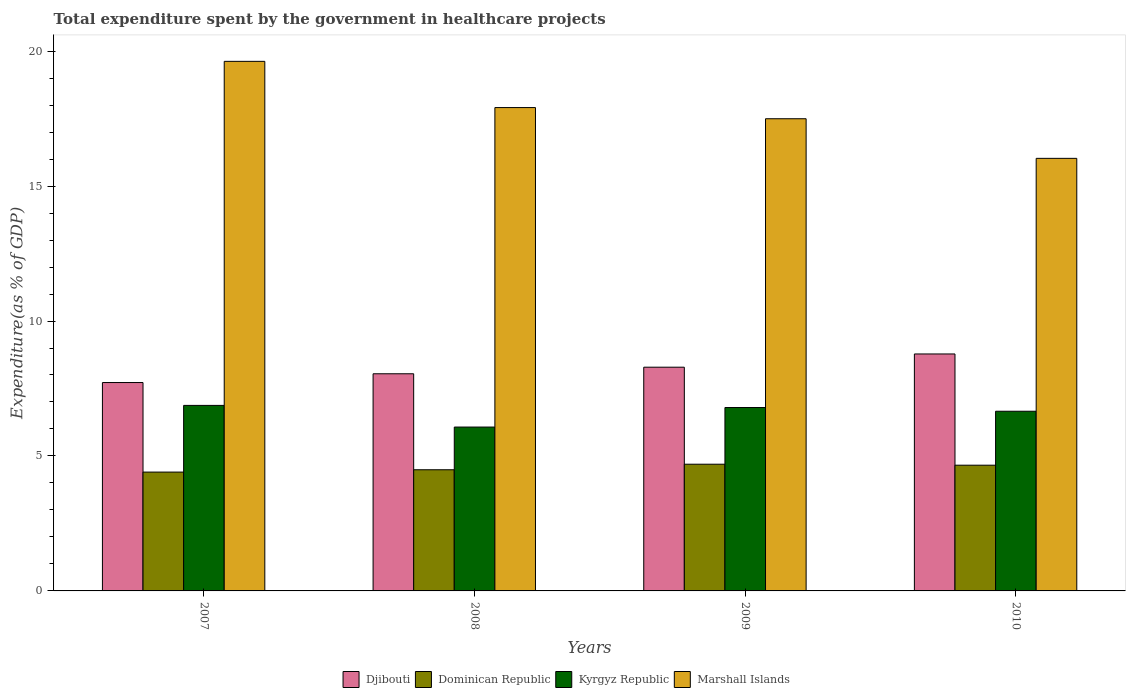Are the number of bars per tick equal to the number of legend labels?
Make the answer very short. Yes. How many bars are there on the 1st tick from the right?
Your answer should be compact. 4. In how many cases, is the number of bars for a given year not equal to the number of legend labels?
Ensure brevity in your answer.  0. What is the total expenditure spent by the government in healthcare projects in Dominican Republic in 2010?
Keep it short and to the point. 4.66. Across all years, what is the maximum total expenditure spent by the government in healthcare projects in Kyrgyz Republic?
Your answer should be compact. 6.87. Across all years, what is the minimum total expenditure spent by the government in healthcare projects in Dominican Republic?
Your answer should be very brief. 4.4. In which year was the total expenditure spent by the government in healthcare projects in Dominican Republic minimum?
Give a very brief answer. 2007. What is the total total expenditure spent by the government in healthcare projects in Djibouti in the graph?
Your answer should be very brief. 32.83. What is the difference between the total expenditure spent by the government in healthcare projects in Dominican Republic in 2009 and that in 2010?
Offer a very short reply. 0.04. What is the difference between the total expenditure spent by the government in healthcare projects in Dominican Republic in 2007 and the total expenditure spent by the government in healthcare projects in Marshall Islands in 2010?
Ensure brevity in your answer.  -11.62. What is the average total expenditure spent by the government in healthcare projects in Kyrgyz Republic per year?
Keep it short and to the point. 6.6. In the year 2008, what is the difference between the total expenditure spent by the government in healthcare projects in Kyrgyz Republic and total expenditure spent by the government in healthcare projects in Dominican Republic?
Your answer should be compact. 1.58. In how many years, is the total expenditure spent by the government in healthcare projects in Dominican Republic greater than 3 %?
Provide a short and direct response. 4. What is the ratio of the total expenditure spent by the government in healthcare projects in Kyrgyz Republic in 2009 to that in 2010?
Give a very brief answer. 1.02. Is the total expenditure spent by the government in healthcare projects in Marshall Islands in 2007 less than that in 2008?
Your response must be concise. No. Is the difference between the total expenditure spent by the government in healthcare projects in Kyrgyz Republic in 2009 and 2010 greater than the difference between the total expenditure spent by the government in healthcare projects in Dominican Republic in 2009 and 2010?
Provide a short and direct response. Yes. What is the difference between the highest and the second highest total expenditure spent by the government in healthcare projects in Kyrgyz Republic?
Your answer should be very brief. 0.08. What is the difference between the highest and the lowest total expenditure spent by the government in healthcare projects in Kyrgyz Republic?
Provide a short and direct response. 0.8. What does the 4th bar from the left in 2009 represents?
Offer a terse response. Marshall Islands. What does the 2nd bar from the right in 2010 represents?
Give a very brief answer. Kyrgyz Republic. How many bars are there?
Ensure brevity in your answer.  16. How many years are there in the graph?
Offer a terse response. 4. Does the graph contain any zero values?
Your answer should be very brief. No. Does the graph contain grids?
Make the answer very short. No. Where does the legend appear in the graph?
Your answer should be compact. Bottom center. How are the legend labels stacked?
Ensure brevity in your answer.  Horizontal. What is the title of the graph?
Make the answer very short. Total expenditure spent by the government in healthcare projects. What is the label or title of the Y-axis?
Ensure brevity in your answer.  Expenditure(as % of GDP). What is the Expenditure(as % of GDP) of Djibouti in 2007?
Your answer should be compact. 7.72. What is the Expenditure(as % of GDP) of Dominican Republic in 2007?
Your answer should be very brief. 4.4. What is the Expenditure(as % of GDP) in Kyrgyz Republic in 2007?
Provide a succinct answer. 6.87. What is the Expenditure(as % of GDP) in Marshall Islands in 2007?
Ensure brevity in your answer.  19.62. What is the Expenditure(as % of GDP) in Djibouti in 2008?
Keep it short and to the point. 8.05. What is the Expenditure(as % of GDP) in Dominican Republic in 2008?
Your response must be concise. 4.49. What is the Expenditure(as % of GDP) of Kyrgyz Republic in 2008?
Give a very brief answer. 6.07. What is the Expenditure(as % of GDP) in Marshall Islands in 2008?
Your answer should be compact. 17.91. What is the Expenditure(as % of GDP) in Djibouti in 2009?
Your answer should be compact. 8.29. What is the Expenditure(as % of GDP) of Dominican Republic in 2009?
Your answer should be very brief. 4.69. What is the Expenditure(as % of GDP) of Kyrgyz Republic in 2009?
Provide a succinct answer. 6.79. What is the Expenditure(as % of GDP) of Marshall Islands in 2009?
Ensure brevity in your answer.  17.49. What is the Expenditure(as % of GDP) in Djibouti in 2010?
Ensure brevity in your answer.  8.78. What is the Expenditure(as % of GDP) in Dominican Republic in 2010?
Offer a very short reply. 4.66. What is the Expenditure(as % of GDP) of Kyrgyz Republic in 2010?
Your answer should be very brief. 6.66. What is the Expenditure(as % of GDP) in Marshall Islands in 2010?
Your response must be concise. 16.03. Across all years, what is the maximum Expenditure(as % of GDP) of Djibouti?
Your answer should be very brief. 8.78. Across all years, what is the maximum Expenditure(as % of GDP) of Dominican Republic?
Your answer should be very brief. 4.69. Across all years, what is the maximum Expenditure(as % of GDP) in Kyrgyz Republic?
Give a very brief answer. 6.87. Across all years, what is the maximum Expenditure(as % of GDP) in Marshall Islands?
Provide a succinct answer. 19.62. Across all years, what is the minimum Expenditure(as % of GDP) in Djibouti?
Ensure brevity in your answer.  7.72. Across all years, what is the minimum Expenditure(as % of GDP) in Dominican Republic?
Offer a terse response. 4.4. Across all years, what is the minimum Expenditure(as % of GDP) of Kyrgyz Republic?
Offer a very short reply. 6.07. Across all years, what is the minimum Expenditure(as % of GDP) of Marshall Islands?
Make the answer very short. 16.03. What is the total Expenditure(as % of GDP) in Djibouti in the graph?
Your answer should be compact. 32.83. What is the total Expenditure(as % of GDP) in Dominican Republic in the graph?
Ensure brevity in your answer.  18.25. What is the total Expenditure(as % of GDP) in Kyrgyz Republic in the graph?
Keep it short and to the point. 26.4. What is the total Expenditure(as % of GDP) in Marshall Islands in the graph?
Your answer should be very brief. 71.05. What is the difference between the Expenditure(as % of GDP) of Djibouti in 2007 and that in 2008?
Offer a very short reply. -0.32. What is the difference between the Expenditure(as % of GDP) of Dominican Republic in 2007 and that in 2008?
Provide a succinct answer. -0.09. What is the difference between the Expenditure(as % of GDP) of Kyrgyz Republic in 2007 and that in 2008?
Keep it short and to the point. 0.8. What is the difference between the Expenditure(as % of GDP) of Marshall Islands in 2007 and that in 2008?
Provide a succinct answer. 1.71. What is the difference between the Expenditure(as % of GDP) in Djibouti in 2007 and that in 2009?
Keep it short and to the point. -0.57. What is the difference between the Expenditure(as % of GDP) of Dominican Republic in 2007 and that in 2009?
Provide a succinct answer. -0.29. What is the difference between the Expenditure(as % of GDP) of Kyrgyz Republic in 2007 and that in 2009?
Provide a succinct answer. 0.08. What is the difference between the Expenditure(as % of GDP) of Marshall Islands in 2007 and that in 2009?
Your answer should be compact. 2.13. What is the difference between the Expenditure(as % of GDP) in Djibouti in 2007 and that in 2010?
Make the answer very short. -1.06. What is the difference between the Expenditure(as % of GDP) of Dominican Republic in 2007 and that in 2010?
Offer a very short reply. -0.26. What is the difference between the Expenditure(as % of GDP) in Kyrgyz Republic in 2007 and that in 2010?
Give a very brief answer. 0.22. What is the difference between the Expenditure(as % of GDP) in Marshall Islands in 2007 and that in 2010?
Provide a succinct answer. 3.59. What is the difference between the Expenditure(as % of GDP) of Djibouti in 2008 and that in 2009?
Provide a short and direct response. -0.24. What is the difference between the Expenditure(as % of GDP) of Dominican Republic in 2008 and that in 2009?
Make the answer very short. -0.21. What is the difference between the Expenditure(as % of GDP) in Kyrgyz Republic in 2008 and that in 2009?
Offer a terse response. -0.72. What is the difference between the Expenditure(as % of GDP) in Marshall Islands in 2008 and that in 2009?
Your answer should be compact. 0.41. What is the difference between the Expenditure(as % of GDP) in Djibouti in 2008 and that in 2010?
Make the answer very short. -0.73. What is the difference between the Expenditure(as % of GDP) of Dominican Republic in 2008 and that in 2010?
Provide a short and direct response. -0.17. What is the difference between the Expenditure(as % of GDP) in Kyrgyz Republic in 2008 and that in 2010?
Provide a succinct answer. -0.59. What is the difference between the Expenditure(as % of GDP) of Marshall Islands in 2008 and that in 2010?
Provide a succinct answer. 1.88. What is the difference between the Expenditure(as % of GDP) in Djibouti in 2009 and that in 2010?
Your answer should be compact. -0.49. What is the difference between the Expenditure(as % of GDP) in Dominican Republic in 2009 and that in 2010?
Provide a short and direct response. 0.04. What is the difference between the Expenditure(as % of GDP) of Kyrgyz Republic in 2009 and that in 2010?
Your answer should be very brief. 0.14. What is the difference between the Expenditure(as % of GDP) of Marshall Islands in 2009 and that in 2010?
Give a very brief answer. 1.47. What is the difference between the Expenditure(as % of GDP) in Djibouti in 2007 and the Expenditure(as % of GDP) in Dominican Republic in 2008?
Provide a succinct answer. 3.23. What is the difference between the Expenditure(as % of GDP) of Djibouti in 2007 and the Expenditure(as % of GDP) of Kyrgyz Republic in 2008?
Provide a succinct answer. 1.65. What is the difference between the Expenditure(as % of GDP) of Djibouti in 2007 and the Expenditure(as % of GDP) of Marshall Islands in 2008?
Ensure brevity in your answer.  -10.19. What is the difference between the Expenditure(as % of GDP) in Dominican Republic in 2007 and the Expenditure(as % of GDP) in Kyrgyz Republic in 2008?
Give a very brief answer. -1.67. What is the difference between the Expenditure(as % of GDP) in Dominican Republic in 2007 and the Expenditure(as % of GDP) in Marshall Islands in 2008?
Offer a very short reply. -13.51. What is the difference between the Expenditure(as % of GDP) of Kyrgyz Republic in 2007 and the Expenditure(as % of GDP) of Marshall Islands in 2008?
Ensure brevity in your answer.  -11.03. What is the difference between the Expenditure(as % of GDP) in Djibouti in 2007 and the Expenditure(as % of GDP) in Dominican Republic in 2009?
Offer a terse response. 3.03. What is the difference between the Expenditure(as % of GDP) in Djibouti in 2007 and the Expenditure(as % of GDP) in Kyrgyz Republic in 2009?
Give a very brief answer. 0.93. What is the difference between the Expenditure(as % of GDP) in Djibouti in 2007 and the Expenditure(as % of GDP) in Marshall Islands in 2009?
Your response must be concise. -9.77. What is the difference between the Expenditure(as % of GDP) of Dominican Republic in 2007 and the Expenditure(as % of GDP) of Kyrgyz Republic in 2009?
Keep it short and to the point. -2.39. What is the difference between the Expenditure(as % of GDP) in Dominican Republic in 2007 and the Expenditure(as % of GDP) in Marshall Islands in 2009?
Your answer should be very brief. -13.09. What is the difference between the Expenditure(as % of GDP) of Kyrgyz Republic in 2007 and the Expenditure(as % of GDP) of Marshall Islands in 2009?
Keep it short and to the point. -10.62. What is the difference between the Expenditure(as % of GDP) in Djibouti in 2007 and the Expenditure(as % of GDP) in Dominican Republic in 2010?
Keep it short and to the point. 3.06. What is the difference between the Expenditure(as % of GDP) in Djibouti in 2007 and the Expenditure(as % of GDP) in Kyrgyz Republic in 2010?
Ensure brevity in your answer.  1.06. What is the difference between the Expenditure(as % of GDP) in Djibouti in 2007 and the Expenditure(as % of GDP) in Marshall Islands in 2010?
Offer a very short reply. -8.31. What is the difference between the Expenditure(as % of GDP) in Dominican Republic in 2007 and the Expenditure(as % of GDP) in Kyrgyz Republic in 2010?
Your answer should be very brief. -2.25. What is the difference between the Expenditure(as % of GDP) in Dominican Republic in 2007 and the Expenditure(as % of GDP) in Marshall Islands in 2010?
Keep it short and to the point. -11.62. What is the difference between the Expenditure(as % of GDP) in Kyrgyz Republic in 2007 and the Expenditure(as % of GDP) in Marshall Islands in 2010?
Keep it short and to the point. -9.15. What is the difference between the Expenditure(as % of GDP) in Djibouti in 2008 and the Expenditure(as % of GDP) in Dominican Republic in 2009?
Offer a terse response. 3.35. What is the difference between the Expenditure(as % of GDP) in Djibouti in 2008 and the Expenditure(as % of GDP) in Kyrgyz Republic in 2009?
Ensure brevity in your answer.  1.25. What is the difference between the Expenditure(as % of GDP) in Djibouti in 2008 and the Expenditure(as % of GDP) in Marshall Islands in 2009?
Give a very brief answer. -9.45. What is the difference between the Expenditure(as % of GDP) in Dominican Republic in 2008 and the Expenditure(as % of GDP) in Kyrgyz Republic in 2009?
Your response must be concise. -2.31. What is the difference between the Expenditure(as % of GDP) in Dominican Republic in 2008 and the Expenditure(as % of GDP) in Marshall Islands in 2009?
Offer a terse response. -13.01. What is the difference between the Expenditure(as % of GDP) in Kyrgyz Republic in 2008 and the Expenditure(as % of GDP) in Marshall Islands in 2009?
Give a very brief answer. -11.42. What is the difference between the Expenditure(as % of GDP) in Djibouti in 2008 and the Expenditure(as % of GDP) in Dominican Republic in 2010?
Provide a short and direct response. 3.39. What is the difference between the Expenditure(as % of GDP) in Djibouti in 2008 and the Expenditure(as % of GDP) in Kyrgyz Republic in 2010?
Offer a terse response. 1.39. What is the difference between the Expenditure(as % of GDP) in Djibouti in 2008 and the Expenditure(as % of GDP) in Marshall Islands in 2010?
Give a very brief answer. -7.98. What is the difference between the Expenditure(as % of GDP) in Dominican Republic in 2008 and the Expenditure(as % of GDP) in Kyrgyz Republic in 2010?
Your answer should be very brief. -2.17. What is the difference between the Expenditure(as % of GDP) in Dominican Republic in 2008 and the Expenditure(as % of GDP) in Marshall Islands in 2010?
Give a very brief answer. -11.54. What is the difference between the Expenditure(as % of GDP) of Kyrgyz Republic in 2008 and the Expenditure(as % of GDP) of Marshall Islands in 2010?
Your response must be concise. -9.96. What is the difference between the Expenditure(as % of GDP) of Djibouti in 2009 and the Expenditure(as % of GDP) of Dominican Republic in 2010?
Your response must be concise. 3.63. What is the difference between the Expenditure(as % of GDP) of Djibouti in 2009 and the Expenditure(as % of GDP) of Kyrgyz Republic in 2010?
Your response must be concise. 1.63. What is the difference between the Expenditure(as % of GDP) of Djibouti in 2009 and the Expenditure(as % of GDP) of Marshall Islands in 2010?
Ensure brevity in your answer.  -7.74. What is the difference between the Expenditure(as % of GDP) in Dominican Republic in 2009 and the Expenditure(as % of GDP) in Kyrgyz Republic in 2010?
Offer a very short reply. -1.96. What is the difference between the Expenditure(as % of GDP) in Dominican Republic in 2009 and the Expenditure(as % of GDP) in Marshall Islands in 2010?
Your response must be concise. -11.33. What is the difference between the Expenditure(as % of GDP) in Kyrgyz Republic in 2009 and the Expenditure(as % of GDP) in Marshall Islands in 2010?
Your answer should be very brief. -9.23. What is the average Expenditure(as % of GDP) in Djibouti per year?
Provide a short and direct response. 8.21. What is the average Expenditure(as % of GDP) in Dominican Republic per year?
Offer a very short reply. 4.56. What is the average Expenditure(as % of GDP) in Kyrgyz Republic per year?
Offer a terse response. 6.6. What is the average Expenditure(as % of GDP) in Marshall Islands per year?
Your answer should be very brief. 17.76. In the year 2007, what is the difference between the Expenditure(as % of GDP) of Djibouti and Expenditure(as % of GDP) of Dominican Republic?
Keep it short and to the point. 3.32. In the year 2007, what is the difference between the Expenditure(as % of GDP) of Djibouti and Expenditure(as % of GDP) of Kyrgyz Republic?
Your response must be concise. 0.85. In the year 2007, what is the difference between the Expenditure(as % of GDP) of Djibouti and Expenditure(as % of GDP) of Marshall Islands?
Offer a terse response. -11.9. In the year 2007, what is the difference between the Expenditure(as % of GDP) of Dominican Republic and Expenditure(as % of GDP) of Kyrgyz Republic?
Your response must be concise. -2.47. In the year 2007, what is the difference between the Expenditure(as % of GDP) in Dominican Republic and Expenditure(as % of GDP) in Marshall Islands?
Give a very brief answer. -15.22. In the year 2007, what is the difference between the Expenditure(as % of GDP) of Kyrgyz Republic and Expenditure(as % of GDP) of Marshall Islands?
Provide a succinct answer. -12.75. In the year 2008, what is the difference between the Expenditure(as % of GDP) in Djibouti and Expenditure(as % of GDP) in Dominican Republic?
Offer a terse response. 3.56. In the year 2008, what is the difference between the Expenditure(as % of GDP) in Djibouti and Expenditure(as % of GDP) in Kyrgyz Republic?
Keep it short and to the point. 1.97. In the year 2008, what is the difference between the Expenditure(as % of GDP) in Djibouti and Expenditure(as % of GDP) in Marshall Islands?
Give a very brief answer. -9.86. In the year 2008, what is the difference between the Expenditure(as % of GDP) of Dominican Republic and Expenditure(as % of GDP) of Kyrgyz Republic?
Your answer should be very brief. -1.58. In the year 2008, what is the difference between the Expenditure(as % of GDP) in Dominican Republic and Expenditure(as % of GDP) in Marshall Islands?
Offer a very short reply. -13.42. In the year 2008, what is the difference between the Expenditure(as % of GDP) of Kyrgyz Republic and Expenditure(as % of GDP) of Marshall Islands?
Offer a terse response. -11.84. In the year 2009, what is the difference between the Expenditure(as % of GDP) of Djibouti and Expenditure(as % of GDP) of Dominican Republic?
Offer a very short reply. 3.59. In the year 2009, what is the difference between the Expenditure(as % of GDP) of Djibouti and Expenditure(as % of GDP) of Kyrgyz Republic?
Ensure brevity in your answer.  1.49. In the year 2009, what is the difference between the Expenditure(as % of GDP) in Djibouti and Expenditure(as % of GDP) in Marshall Islands?
Ensure brevity in your answer.  -9.2. In the year 2009, what is the difference between the Expenditure(as % of GDP) in Dominican Republic and Expenditure(as % of GDP) in Kyrgyz Republic?
Provide a short and direct response. -2.1. In the year 2009, what is the difference between the Expenditure(as % of GDP) in Dominican Republic and Expenditure(as % of GDP) in Marshall Islands?
Ensure brevity in your answer.  -12.8. In the year 2009, what is the difference between the Expenditure(as % of GDP) of Kyrgyz Republic and Expenditure(as % of GDP) of Marshall Islands?
Make the answer very short. -10.7. In the year 2010, what is the difference between the Expenditure(as % of GDP) of Djibouti and Expenditure(as % of GDP) of Dominican Republic?
Your answer should be compact. 4.12. In the year 2010, what is the difference between the Expenditure(as % of GDP) of Djibouti and Expenditure(as % of GDP) of Kyrgyz Republic?
Your answer should be compact. 2.12. In the year 2010, what is the difference between the Expenditure(as % of GDP) in Djibouti and Expenditure(as % of GDP) in Marshall Islands?
Keep it short and to the point. -7.25. In the year 2010, what is the difference between the Expenditure(as % of GDP) in Dominican Republic and Expenditure(as % of GDP) in Kyrgyz Republic?
Ensure brevity in your answer.  -2. In the year 2010, what is the difference between the Expenditure(as % of GDP) in Dominican Republic and Expenditure(as % of GDP) in Marshall Islands?
Keep it short and to the point. -11.37. In the year 2010, what is the difference between the Expenditure(as % of GDP) of Kyrgyz Republic and Expenditure(as % of GDP) of Marshall Islands?
Make the answer very short. -9.37. What is the ratio of the Expenditure(as % of GDP) of Djibouti in 2007 to that in 2008?
Provide a succinct answer. 0.96. What is the ratio of the Expenditure(as % of GDP) of Dominican Republic in 2007 to that in 2008?
Make the answer very short. 0.98. What is the ratio of the Expenditure(as % of GDP) of Kyrgyz Republic in 2007 to that in 2008?
Give a very brief answer. 1.13. What is the ratio of the Expenditure(as % of GDP) of Marshall Islands in 2007 to that in 2008?
Your response must be concise. 1.1. What is the ratio of the Expenditure(as % of GDP) in Djibouti in 2007 to that in 2009?
Offer a very short reply. 0.93. What is the ratio of the Expenditure(as % of GDP) of Dominican Republic in 2007 to that in 2009?
Your response must be concise. 0.94. What is the ratio of the Expenditure(as % of GDP) of Kyrgyz Republic in 2007 to that in 2009?
Offer a terse response. 1.01. What is the ratio of the Expenditure(as % of GDP) in Marshall Islands in 2007 to that in 2009?
Your answer should be very brief. 1.12. What is the ratio of the Expenditure(as % of GDP) of Djibouti in 2007 to that in 2010?
Keep it short and to the point. 0.88. What is the ratio of the Expenditure(as % of GDP) of Dominican Republic in 2007 to that in 2010?
Provide a succinct answer. 0.95. What is the ratio of the Expenditure(as % of GDP) of Kyrgyz Republic in 2007 to that in 2010?
Make the answer very short. 1.03. What is the ratio of the Expenditure(as % of GDP) in Marshall Islands in 2007 to that in 2010?
Offer a terse response. 1.22. What is the ratio of the Expenditure(as % of GDP) in Djibouti in 2008 to that in 2009?
Offer a terse response. 0.97. What is the ratio of the Expenditure(as % of GDP) of Dominican Republic in 2008 to that in 2009?
Give a very brief answer. 0.96. What is the ratio of the Expenditure(as % of GDP) in Kyrgyz Republic in 2008 to that in 2009?
Your answer should be very brief. 0.89. What is the ratio of the Expenditure(as % of GDP) of Marshall Islands in 2008 to that in 2009?
Provide a short and direct response. 1.02. What is the ratio of the Expenditure(as % of GDP) in Djibouti in 2008 to that in 2010?
Provide a short and direct response. 0.92. What is the ratio of the Expenditure(as % of GDP) of Dominican Republic in 2008 to that in 2010?
Provide a succinct answer. 0.96. What is the ratio of the Expenditure(as % of GDP) of Kyrgyz Republic in 2008 to that in 2010?
Provide a succinct answer. 0.91. What is the ratio of the Expenditure(as % of GDP) of Marshall Islands in 2008 to that in 2010?
Your response must be concise. 1.12. What is the ratio of the Expenditure(as % of GDP) in Djibouti in 2009 to that in 2010?
Provide a succinct answer. 0.94. What is the ratio of the Expenditure(as % of GDP) of Dominican Republic in 2009 to that in 2010?
Your answer should be very brief. 1.01. What is the ratio of the Expenditure(as % of GDP) in Kyrgyz Republic in 2009 to that in 2010?
Ensure brevity in your answer.  1.02. What is the ratio of the Expenditure(as % of GDP) in Marshall Islands in 2009 to that in 2010?
Offer a terse response. 1.09. What is the difference between the highest and the second highest Expenditure(as % of GDP) of Djibouti?
Keep it short and to the point. 0.49. What is the difference between the highest and the second highest Expenditure(as % of GDP) in Dominican Republic?
Your answer should be compact. 0.04. What is the difference between the highest and the second highest Expenditure(as % of GDP) in Kyrgyz Republic?
Offer a terse response. 0.08. What is the difference between the highest and the second highest Expenditure(as % of GDP) in Marshall Islands?
Your answer should be very brief. 1.71. What is the difference between the highest and the lowest Expenditure(as % of GDP) of Djibouti?
Provide a short and direct response. 1.06. What is the difference between the highest and the lowest Expenditure(as % of GDP) in Dominican Republic?
Offer a terse response. 0.29. What is the difference between the highest and the lowest Expenditure(as % of GDP) in Kyrgyz Republic?
Your response must be concise. 0.8. What is the difference between the highest and the lowest Expenditure(as % of GDP) of Marshall Islands?
Give a very brief answer. 3.59. 